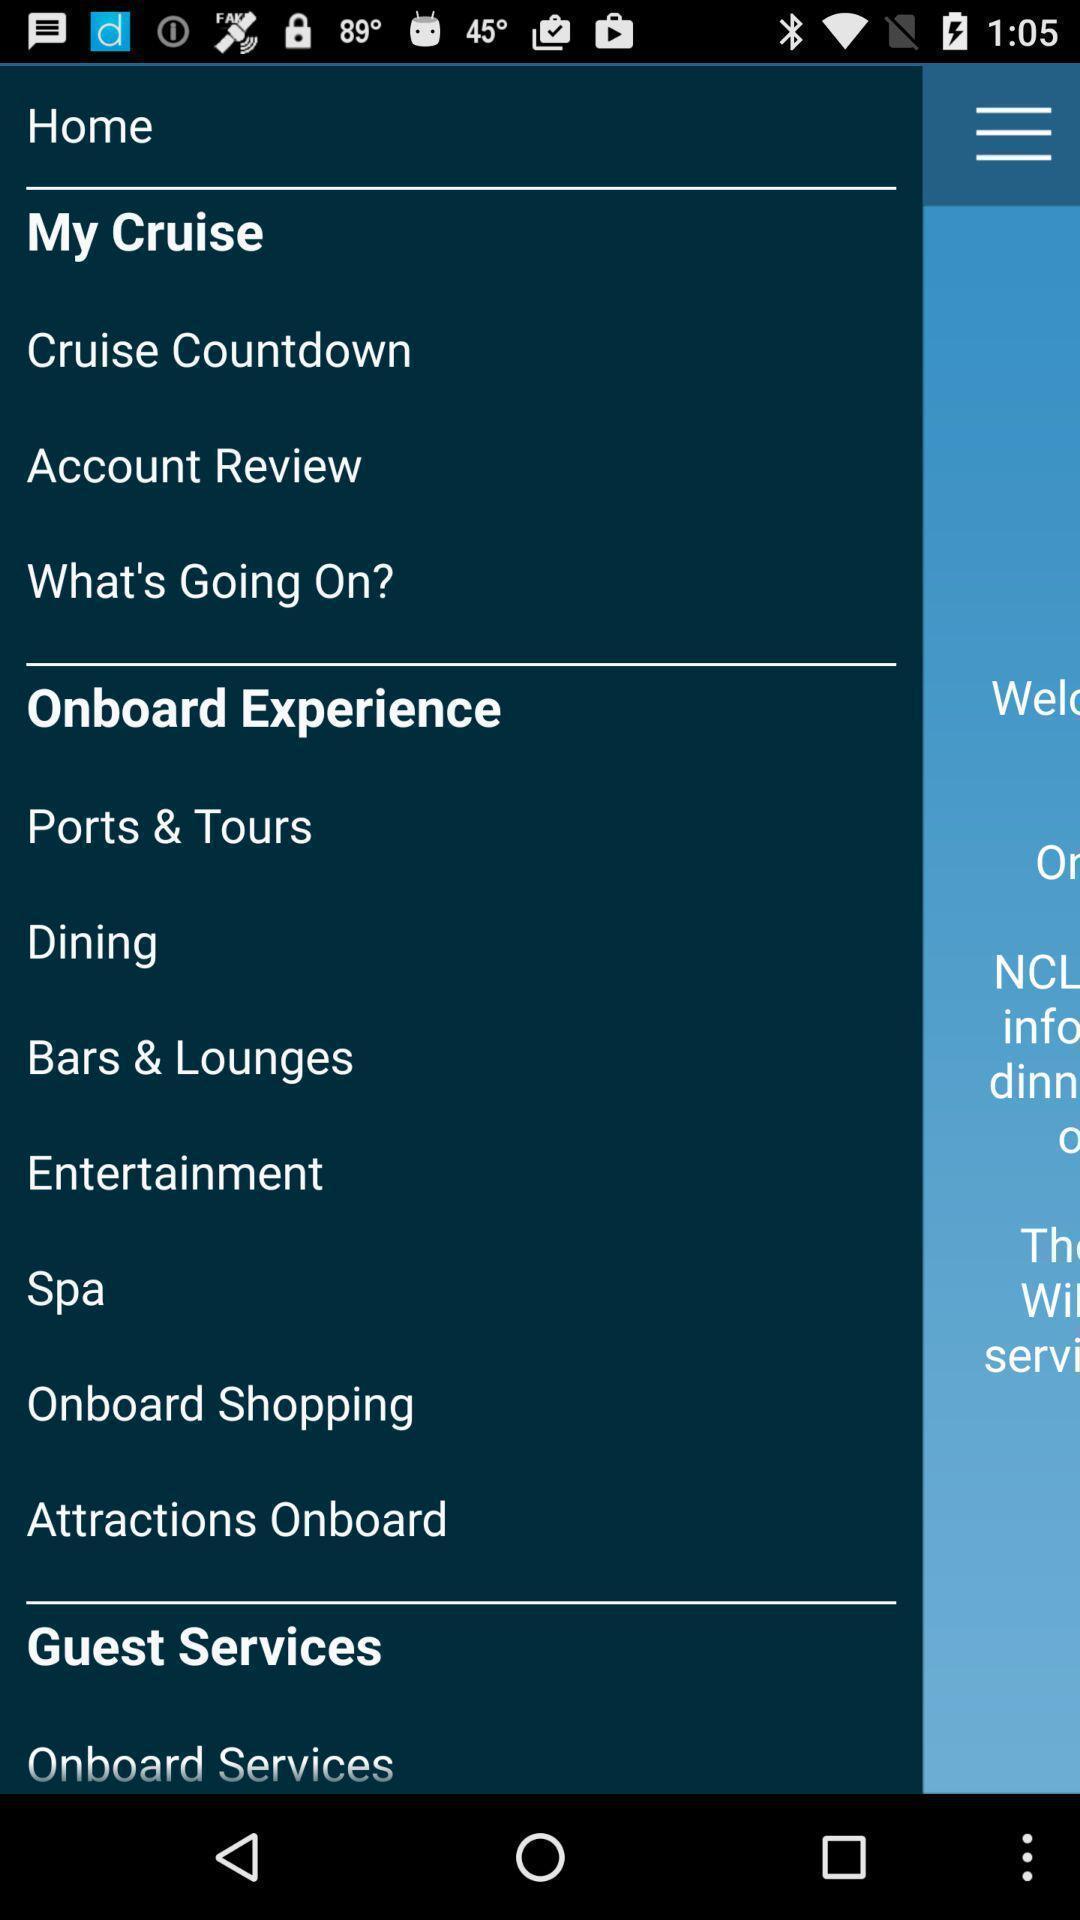Describe the visual elements of this screenshot. Page displaying menu options of the app. 